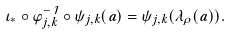<formula> <loc_0><loc_0><loc_500><loc_500>\iota _ { * } \circ \varphi _ { j , k } ^ { - 1 } \circ \psi _ { j , k } ( a ) = \psi _ { j , k } ( \lambda _ { \rho } ( a ) ) .</formula> 